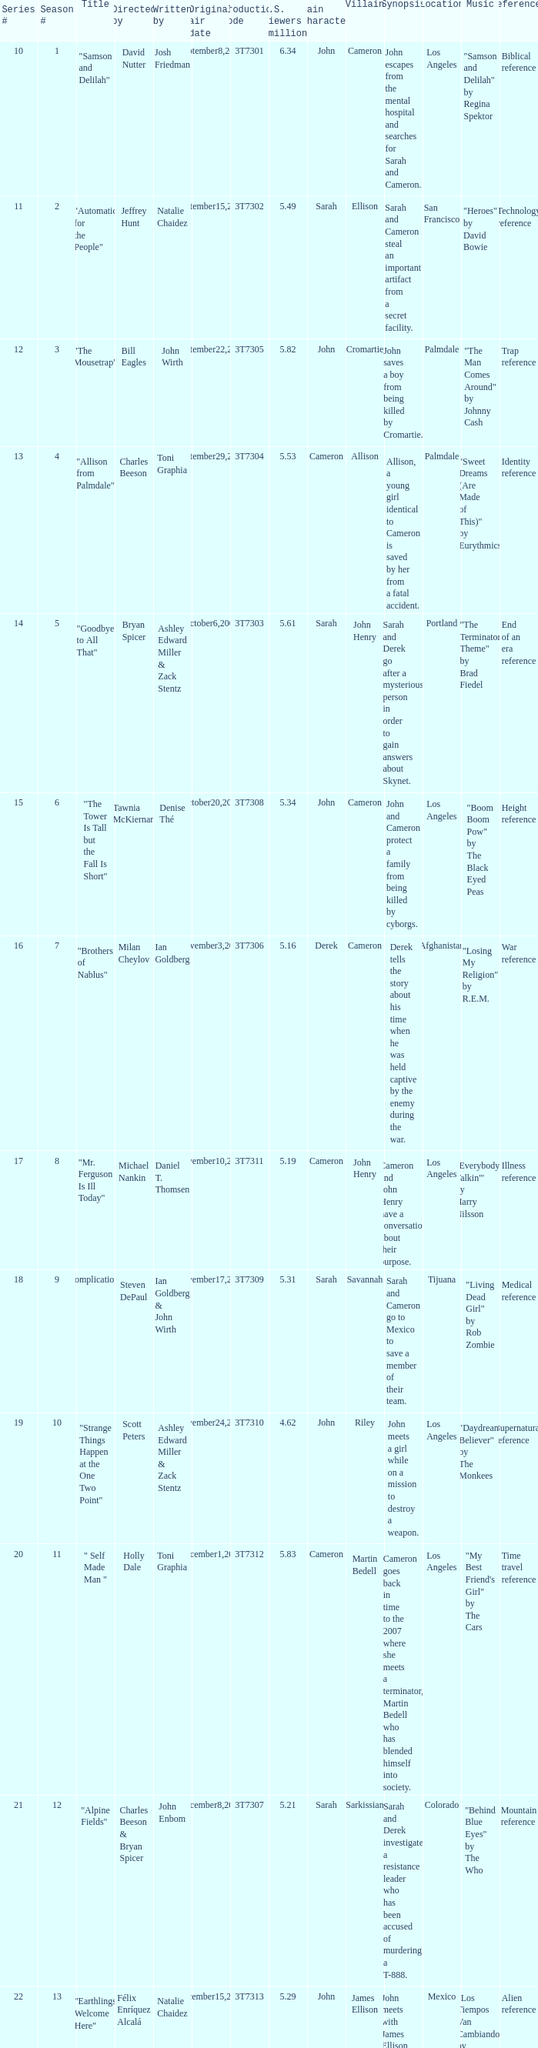Which episode number drew in 3.84 million viewers in the U.S.? 24.0. 